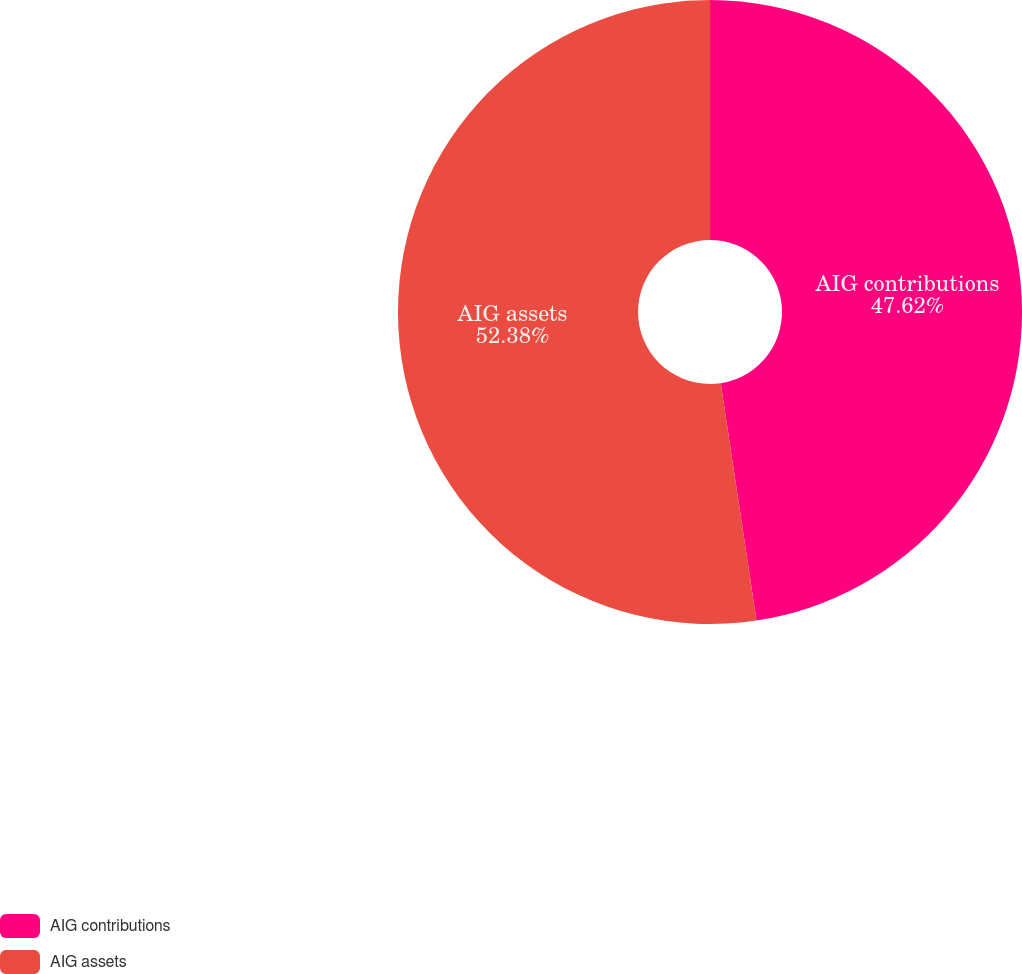Convert chart. <chart><loc_0><loc_0><loc_500><loc_500><pie_chart><fcel>AIG contributions<fcel>AIG assets<nl><fcel>47.62%<fcel>52.38%<nl></chart> 